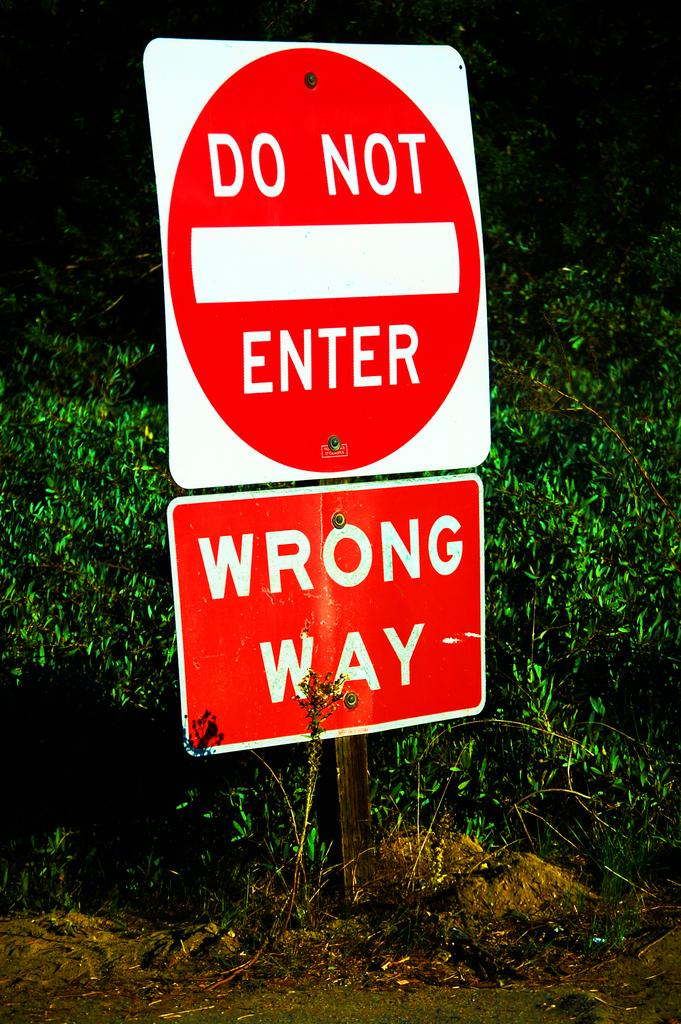What is the main object in the image? There is a sign board in the image. What can be seen in the background of the image? There are green plants visible in the background. What type of vegetation is at the bottom of the image? There is grass at the bottom of the image. What is visible beneath the sign board and grass? The ground is visible in the image. What direction is the camera facing in the image? The image does not show the camera or its orientation, so it cannot be determined from the image. 